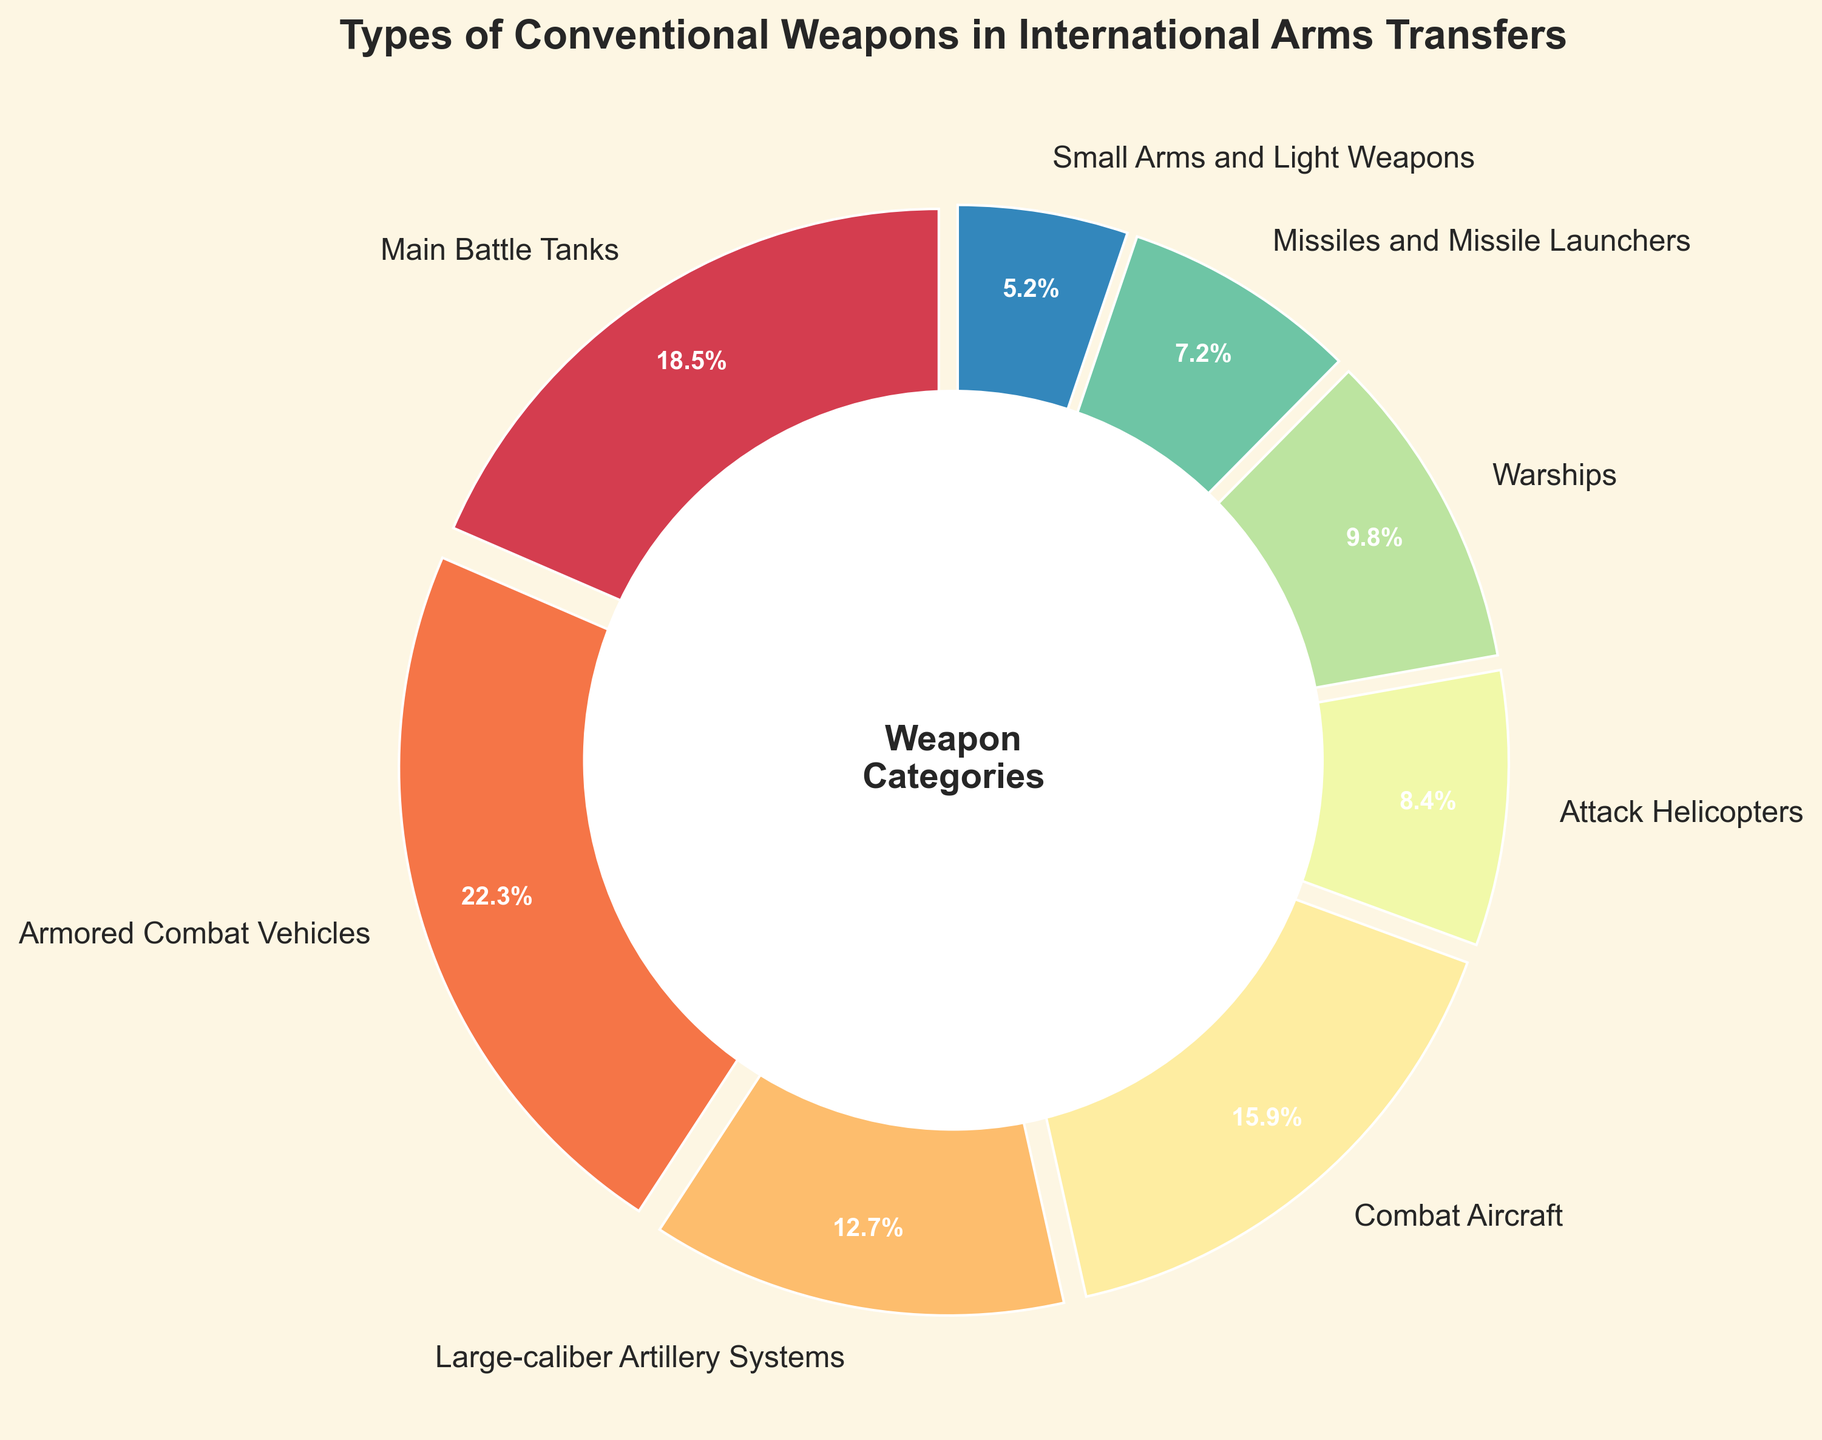Which category has the highest percentage in the pie chart? By looking at the chart and comparing the proportions, it is clear that "Armored Combat Vehicles" has the largest slice.
Answer: Armored Combat Vehicles Which category has the lowest percentage in the pie chart? By referring to the figure and comparing the smallest slice, it is evident that "Small Arms and Light Weapons" has the lowest percentage.
Answer: Small Arms and Light Weapons What is the total percentage of Main Battle Tanks and Combat Aircraft? To find the total percentage, add the values for Main Battle Tanks (18.5%) and Combat Aircraft (15.9%). So, 18.5 + 15.9 = 34.4.
Answer: 34.4 How many categories have a percentage greater than 10%? Identifying the categories, we have Main Battle Tanks, Armored Combat Vehicles, Large-caliber Artillery Systems, and Combat Aircraft, which totals to 4 categories.
Answer: 4 Is the percentage of Warships greater than the percentage of Attack Helicopters? By comparing their respective slices in the pie chart, Warships have 9.8% whereas Attack Helicopters have 8.4%. Yes, Warships have a higher percentage.
Answer: Yes What color represents the category with the largest percentage? Looking at the visual attributes of the pie chart, the largest slice, representing Armored Combat Vehicles, is colored in a specific shade from the Spectral colormap (most likely a brighter color).
Answer: Depends on the specific color in your chart What is the difference in percentage between Large-caliber Artillery Systems and Missiles and Missile Launchers? To find the difference, subtract the percentage of Missiles and Missile Launchers (7.2%) from that of Large-caliber Artillery Systems (12.7%). So, 12.7 - 7.2 = 5.5.
Answer: 5.5 What is the cumulative percentage of the three smallest categories? Add the percentages of the three smallest categories: Small Arms and Light Weapons (5.2%), Missiles and Missile Launchers (7.2%), and Attack Helicopters (8.4%). So, 5.2 + 7.2 + 8.4 = 20.8.
Answer: 20.8 Which category is represented by a red color in the pie chart? By observing the colors and their corresponding labels, determine which slice is colored red. The exact category will depend on your specific color assignment.
Answer: Depends on the specific color in your chart Are there more categories below or above 10% in the chart? By counting the number of categories above 10% (Main Battle Tanks, Armored Combat Vehicles, Large-caliber Artillery Systems, Combat Aircraft, and Warships: 5 categories) and below 10% (Attack Helicopters, Missiles and Missile Launchers, and Small Arms and Light Weapons: 3 categories), more categories are above 10%.
Answer: Above 